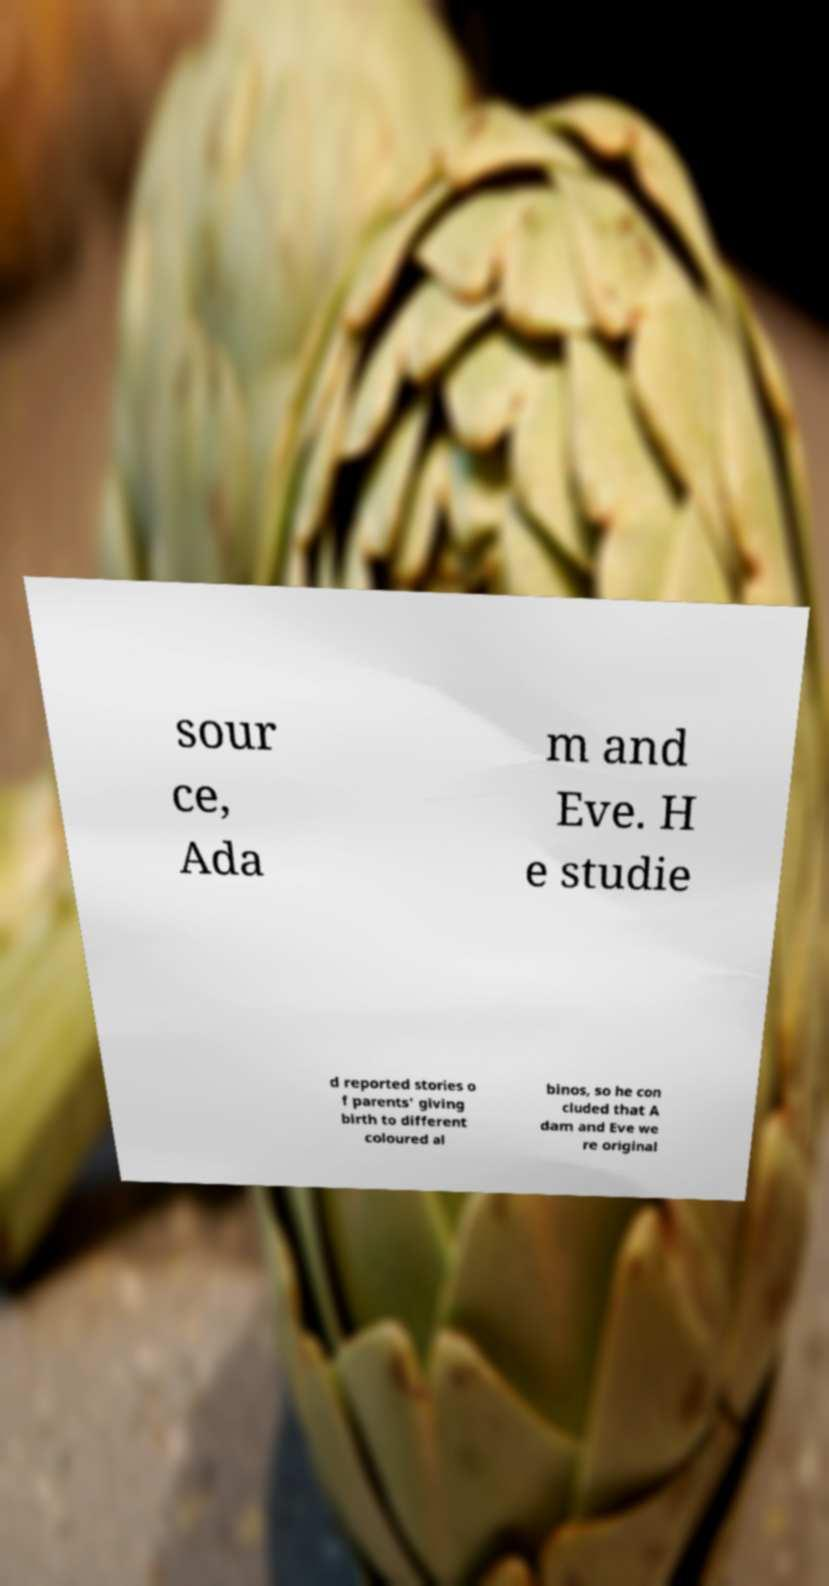What messages or text are displayed in this image? I need them in a readable, typed format. sour ce, Ada m and Eve. H e studie d reported stories o f parents' giving birth to different coloured al binos, so he con cluded that A dam and Eve we re original 